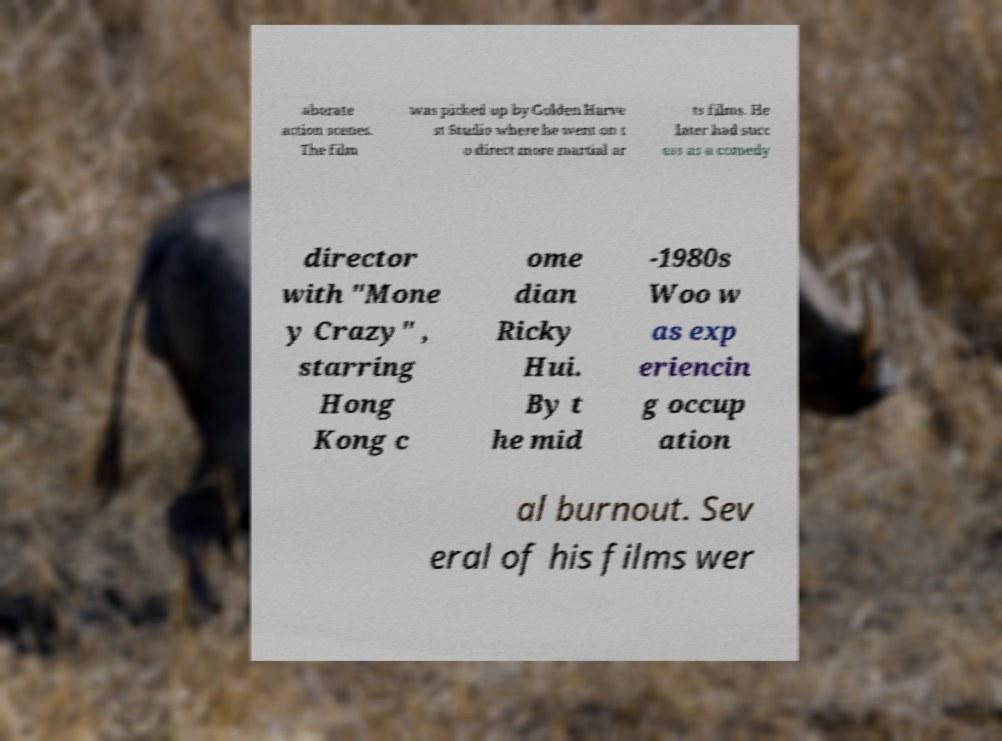Could you extract and type out the text from this image? aborate action scenes. The film was picked up by Golden Harve st Studio where he went on t o direct more martial ar ts films. He later had succ ess as a comedy director with "Mone y Crazy" , starring Hong Kong c ome dian Ricky Hui. By t he mid -1980s Woo w as exp eriencin g occup ation al burnout. Sev eral of his films wer 